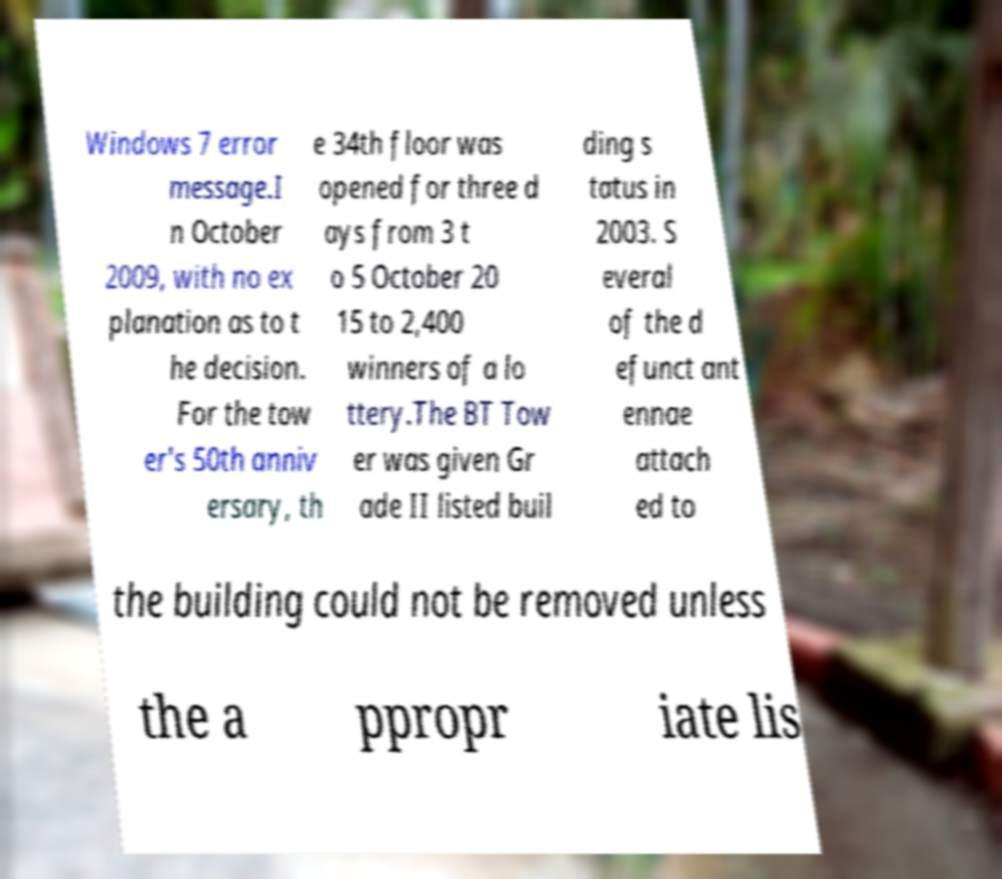What messages or text are displayed in this image? I need them in a readable, typed format. Windows 7 error message.I n October 2009, with no ex planation as to t he decision. For the tow er's 50th anniv ersary, th e 34th floor was opened for three d ays from 3 t o 5 October 20 15 to 2,400 winners of a lo ttery.The BT Tow er was given Gr ade II listed buil ding s tatus in 2003. S everal of the d efunct ant ennae attach ed to the building could not be removed unless the a ppropr iate lis 